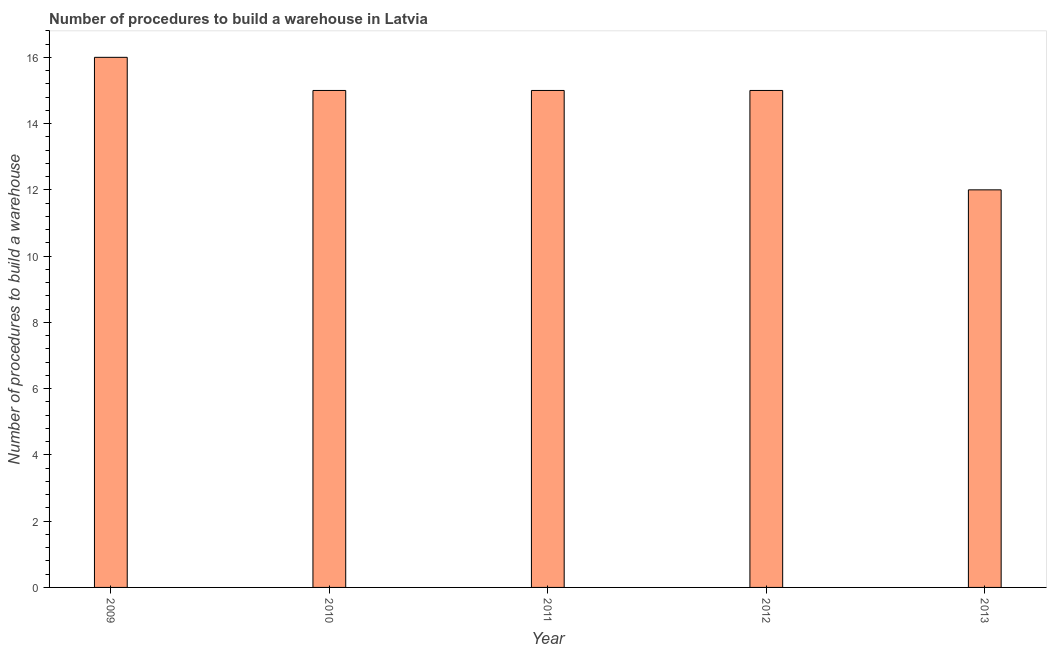What is the title of the graph?
Provide a short and direct response. Number of procedures to build a warehouse in Latvia. What is the label or title of the Y-axis?
Provide a succinct answer. Number of procedures to build a warehouse. Across all years, what is the maximum number of procedures to build a warehouse?
Your answer should be very brief. 16. In which year was the number of procedures to build a warehouse minimum?
Offer a very short reply. 2013. What is the ratio of the number of procedures to build a warehouse in 2009 to that in 2013?
Ensure brevity in your answer.  1.33. Is the number of procedures to build a warehouse in 2009 less than that in 2010?
Provide a succinct answer. No. Is the difference between the number of procedures to build a warehouse in 2010 and 2012 greater than the difference between any two years?
Offer a terse response. No. Are all the bars in the graph horizontal?
Your answer should be very brief. No. How many years are there in the graph?
Keep it short and to the point. 5. Are the values on the major ticks of Y-axis written in scientific E-notation?
Your answer should be compact. No. What is the Number of procedures to build a warehouse in 2010?
Your answer should be very brief. 15. What is the Number of procedures to build a warehouse in 2011?
Give a very brief answer. 15. What is the Number of procedures to build a warehouse of 2013?
Offer a terse response. 12. What is the difference between the Number of procedures to build a warehouse in 2009 and 2010?
Your answer should be very brief. 1. What is the difference between the Number of procedures to build a warehouse in 2009 and 2012?
Offer a terse response. 1. What is the difference between the Number of procedures to build a warehouse in 2010 and 2011?
Ensure brevity in your answer.  0. What is the difference between the Number of procedures to build a warehouse in 2010 and 2013?
Provide a succinct answer. 3. What is the difference between the Number of procedures to build a warehouse in 2011 and 2012?
Your response must be concise. 0. What is the difference between the Number of procedures to build a warehouse in 2011 and 2013?
Provide a succinct answer. 3. What is the ratio of the Number of procedures to build a warehouse in 2009 to that in 2010?
Make the answer very short. 1.07. What is the ratio of the Number of procedures to build a warehouse in 2009 to that in 2011?
Provide a succinct answer. 1.07. What is the ratio of the Number of procedures to build a warehouse in 2009 to that in 2012?
Give a very brief answer. 1.07. What is the ratio of the Number of procedures to build a warehouse in 2009 to that in 2013?
Your response must be concise. 1.33. What is the ratio of the Number of procedures to build a warehouse in 2010 to that in 2012?
Provide a short and direct response. 1. What is the ratio of the Number of procedures to build a warehouse in 2011 to that in 2012?
Ensure brevity in your answer.  1. 